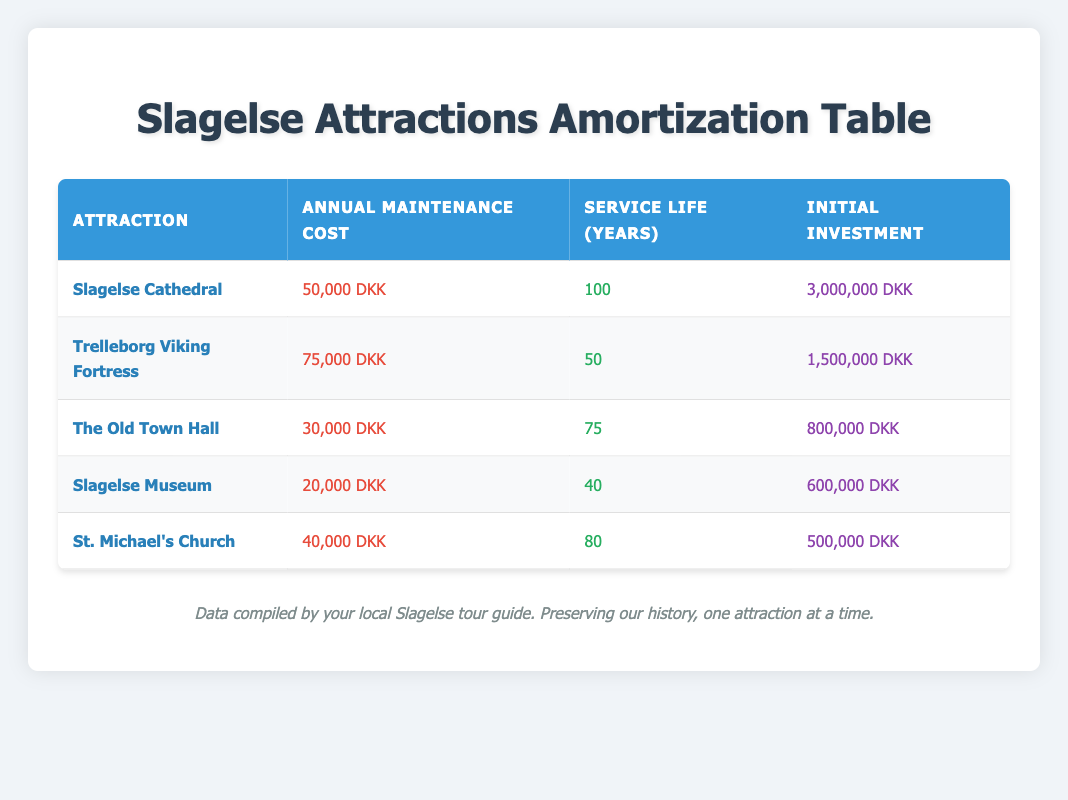What is the annual maintenance cost for Slagelse Museum? The annual maintenance cost for Slagelse Museum, as stated directly in the table, is 20,000 DKK.
Answer: 20,000 DKK Which attraction has the highest annual maintenance cost? By reviewing the table, Trelleborg Viking Fortress has the highest annual maintenance cost at 75,000 DKK.
Answer: Trelleborg Viking Fortress What is the service life of Slagelse Cathedral? The table shows that the service life of Slagelse Cathedral is 100 years.
Answer: 100 years Is the initial investment for The Old Town Hall greater than 700,000 DKK? The initial investment for The Old Town Hall is 800,000 DKK, which is greater than 700,000 DKK, making this statement true.
Answer: Yes What is the total initial investment for all attractions combined? To find the total initial investment, we sum the initial investments: 3,000,000 (Cathedral) + 1,500,000 (Viking Fortress) + 800,000 (Old Town Hall) + 600,000 (Museum) + 500,000 (St. Michael's Church) = 6,400,000 DKK.
Answer: 6,400,000 DKK Which attraction has the lowest annual maintenance cost? By checking the table, Slagelse Museum has the lowest annual maintenance cost at 20,000 DKK.
Answer: Slagelse Museum What is the average annual maintenance cost across all attractions? First, we calculate the total maintenance cost: 50,000 + 75,000 + 30,000 + 20,000 + 40,000 = 215,000 DKK. Dividing by the number of attractions (5), the average is 215,000 / 5 = 43,000 DKK.
Answer: 43,000 DKK Is St. Michael's Church service life greater than 70 years? The service life of St. Michael's Church is 80 years, which is indeed greater than 70 years, making this statement true.
Answer: Yes What are the total annual maintenance costs for attractions with a service life of less than 50 years? The attractions with a service life of less than 50 years are Trelleborg Viking Fortress (50 years) and Slagelse Museum (40 years). Their respective maintenance costs are 75,000 DKK and 20,000 DKK. Since only Slagelse Museum qualifies, the total is 20,000 DKK.
Answer: 20,000 DKK 